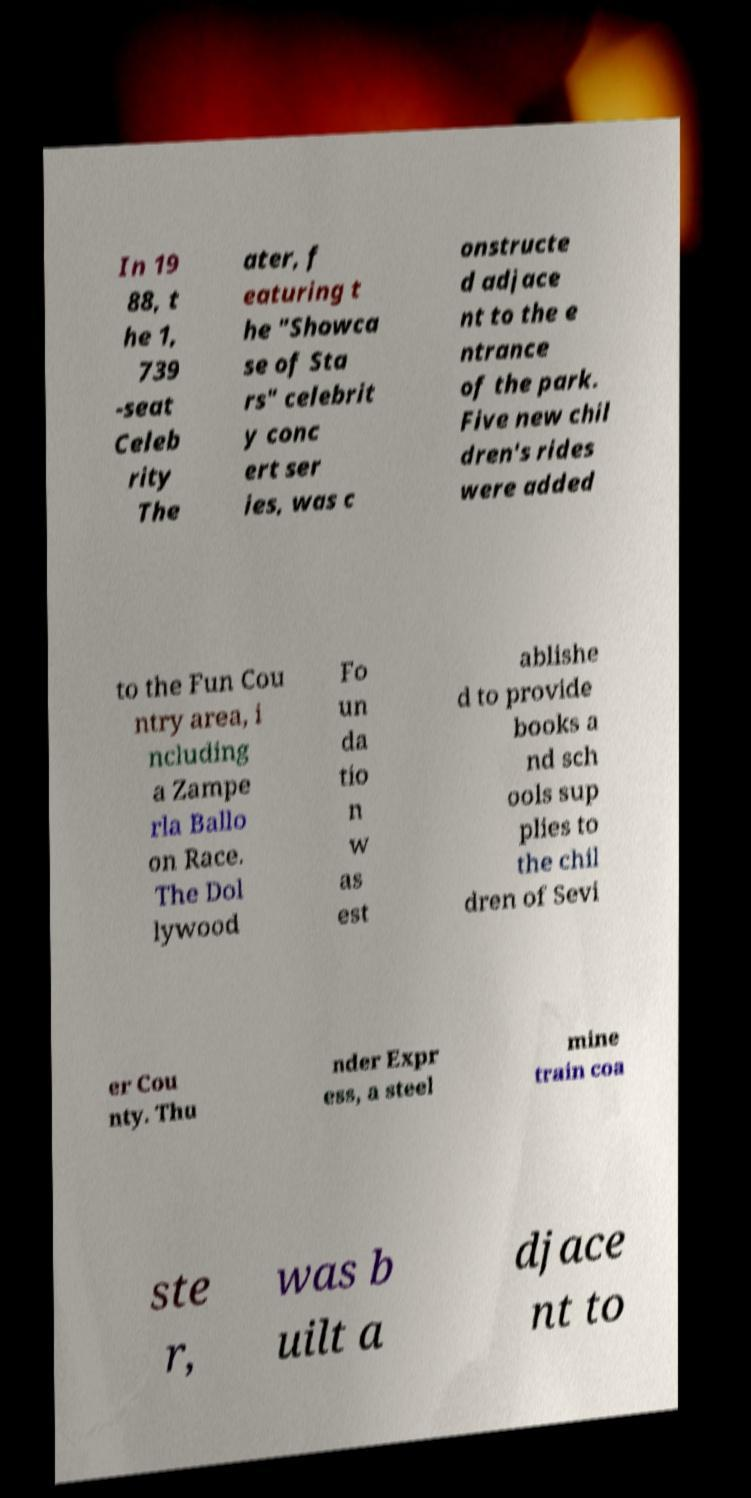Can you read and provide the text displayed in the image?This photo seems to have some interesting text. Can you extract and type it out for me? In 19 88, t he 1, 739 -seat Celeb rity The ater, f eaturing t he "Showca se of Sta rs" celebrit y conc ert ser ies, was c onstructe d adjace nt to the e ntrance of the park. Five new chil dren's rides were added to the Fun Cou ntry area, i ncluding a Zampe rla Ballo on Race. The Dol lywood Fo un da tio n w as est ablishe d to provide books a nd sch ools sup plies to the chil dren of Sevi er Cou nty. Thu nder Expr ess, a steel mine train coa ste r, was b uilt a djace nt to 